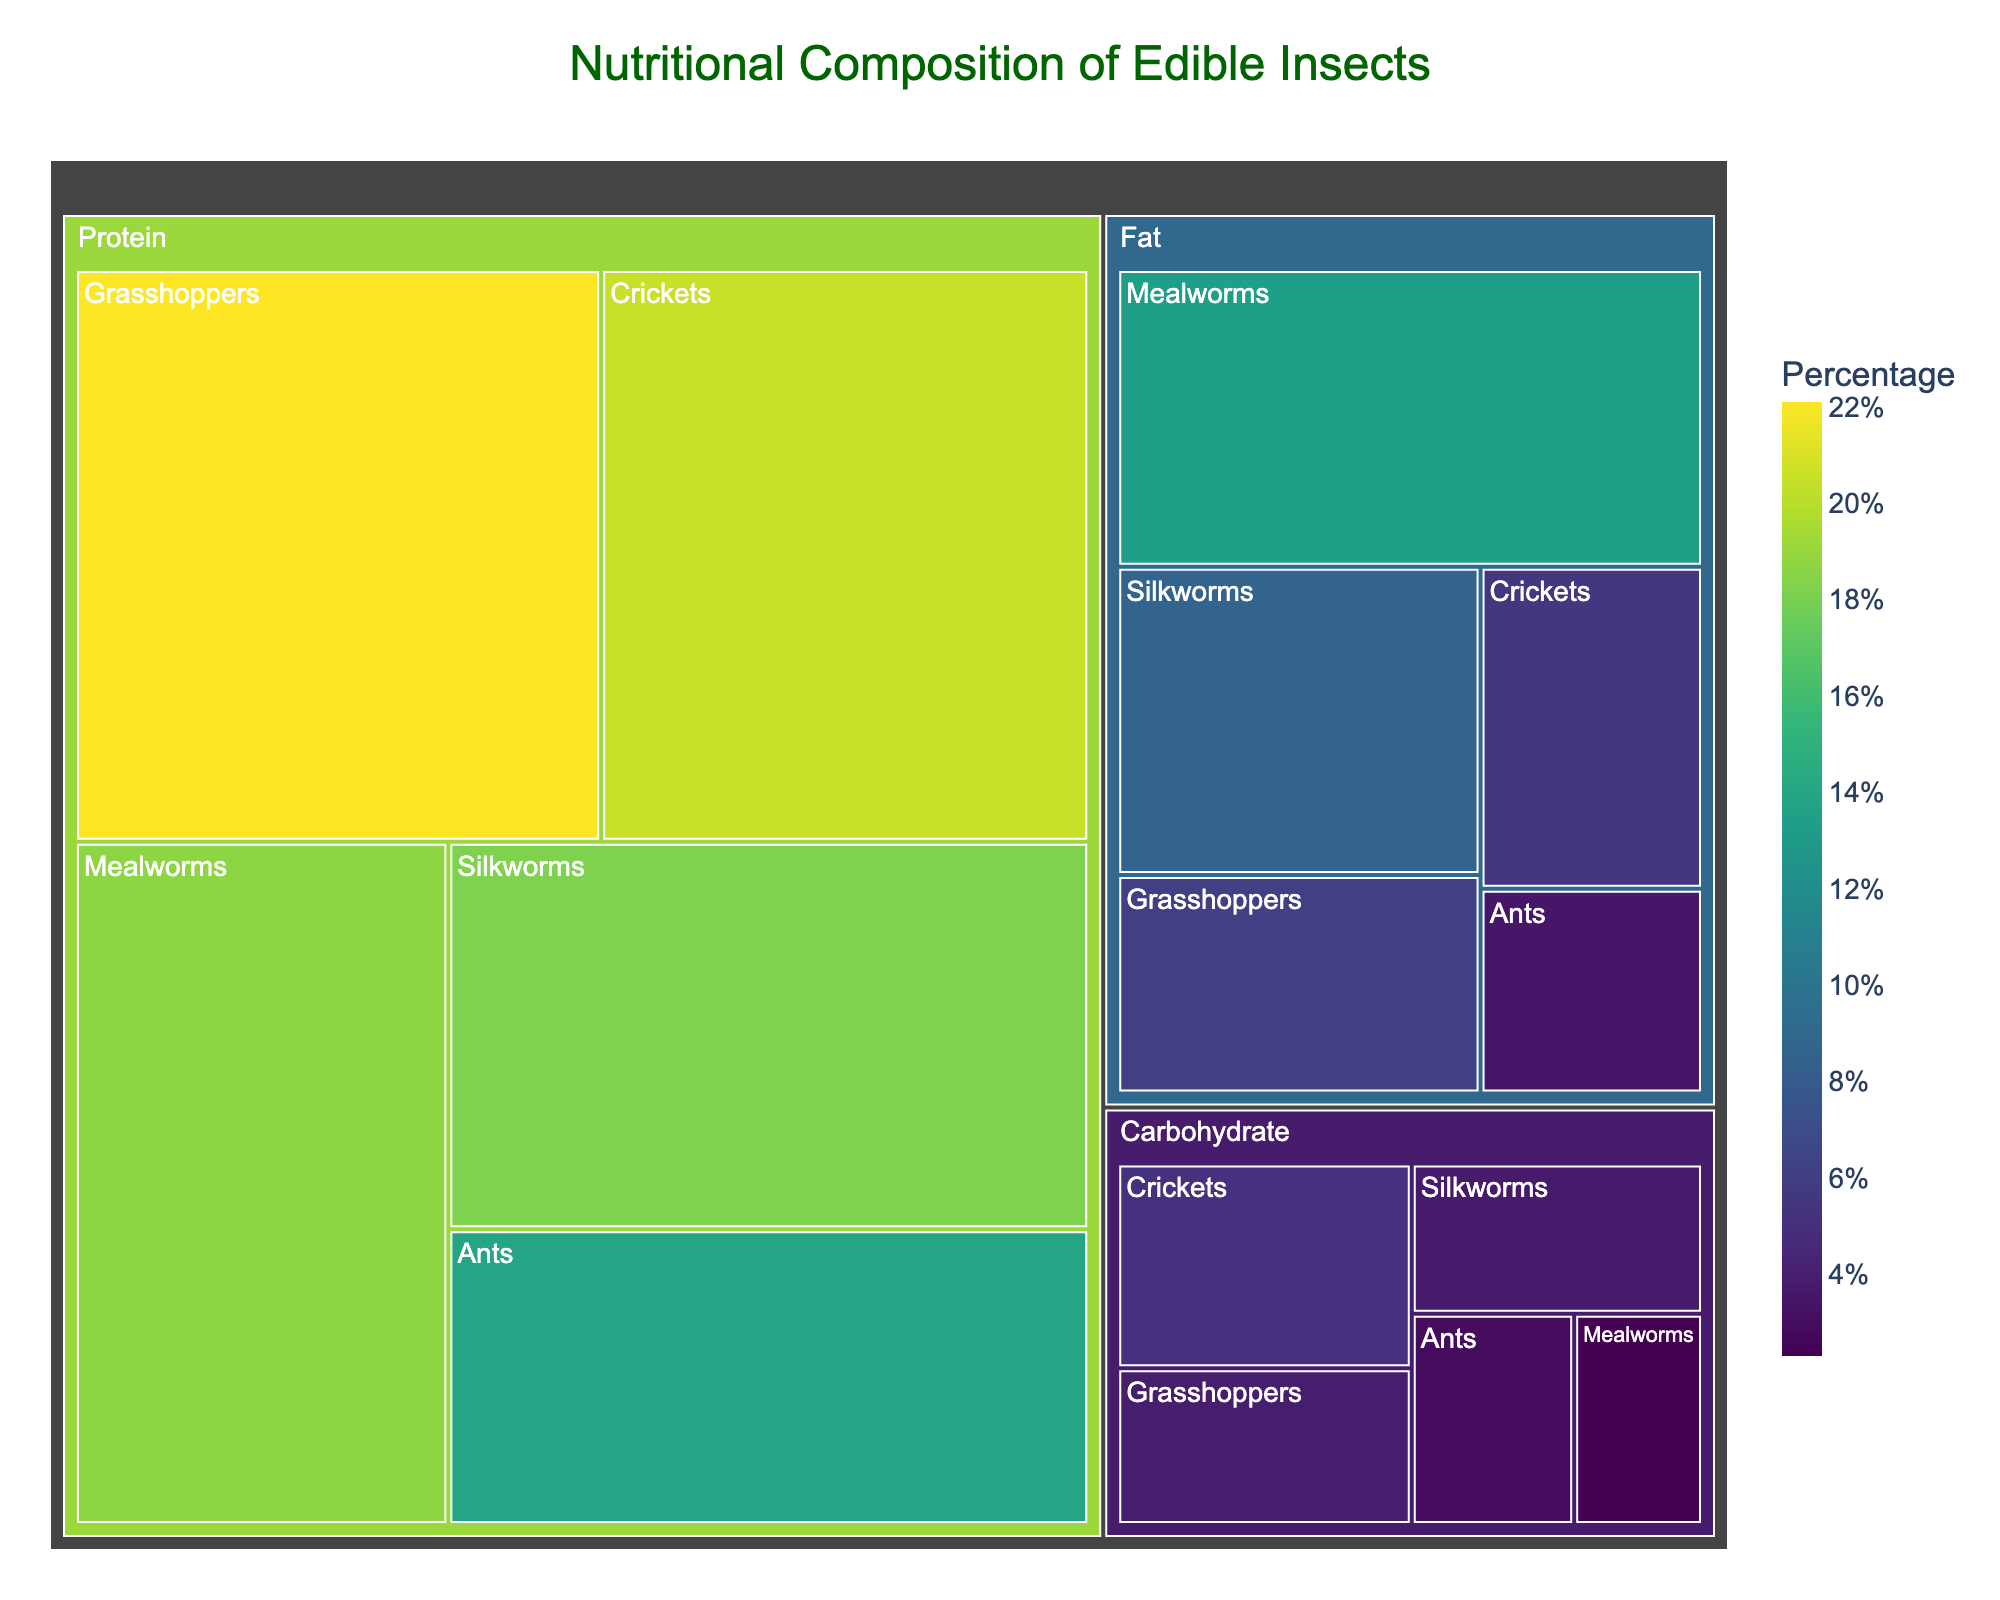what is the title of the figure? Look at the top of the figure where titles are usually placed. The title is given at the center aligned to provide context.
Answer: Nutritional Composition of Edible Insects Which insect has the highest protein content? Analyze the treemap sections under the "Protein" category. The section with the largest size indicates the highest protein content.
Answer: Grasshoppers Which insect has the lowest fat content? Examine the treemap sections under the "Fat" category and identify the smallest section.
Answer: Ants What is the combined percentage of fat for Crickets and Grasshoppers? Look at the "Fat" category and sum the percentages for Crickets and Grasshoppers: 5.5% (Crickets) + 6.1% (Grasshoppers) = 11.6%
Answer: 11.6% Which category has the smallest range of percentages within its subcategories? Calculate the range (difference between the highest and the lowest) for each category: 
Protein: 22.1% (highest) - 13.9% (lowest) = 8.2%
Fat: 13.4% - 3.5% = 9.9%
Carbohydrate: 5.1% - 2.3% = 2.8%
The smallest range is in Carbohydrate.
Answer: Carbohydrate How does the protein content of Silkworms compare to that of Mealworms? Compare the percentages of protein within the "Protein" category for both Silkworms and Mealworms. Silkworms (18.2%), Mealworms (18.7%).
Answer: Silkworms have slightly less protein than Mealworms Which insect has the highest carbohydrate content? Look for the largest section under the "Carbohydrate" category. This indicates the highest carbohydrate content.
Answer: Crickets What is the average protein content across all insects? Sum the protein percentages of all insects and divide by the number of insects:
(20.5 + 18.7 + 22.1 + 13.9 + 18.2) / 5 = 93.4 / 5 = 18.68.
Answer: 18.68% What is the total carbohydrate content for Ants and Silkworms? Add the percentages under the "Carbohydrate" category for Ants and Silkworms: 2.9% (Ants) + 3.7% (Silkworms) = 6.6%
Answer: 6.6% In which category do Crickets have the highest percentage? Compare the percentages of Crickets across Protein, Fat, and Carbohydrate categories: Protein (20.5%), Fat (5.5%), Carbohydrate (5.1%). The highest is in Protein.
Answer: Protein 